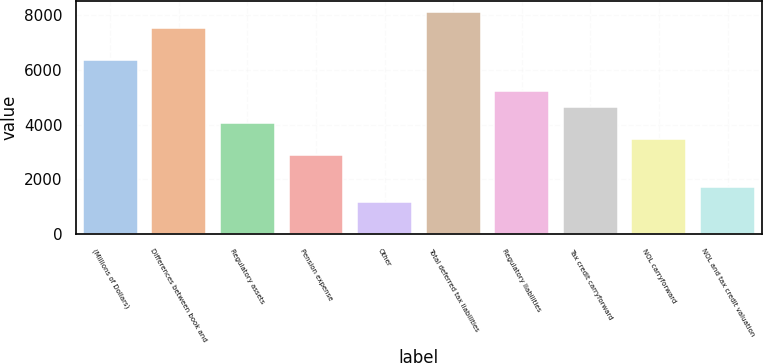<chart> <loc_0><loc_0><loc_500><loc_500><bar_chart><fcel>(Millions of Dollars)<fcel>Differences between book and<fcel>Regulatory assets<fcel>Pension expense<fcel>Other<fcel>Total deferred tax liabilities<fcel>Regulatory liabilities<fcel>Tax credit carryforward<fcel>NOL carryforward<fcel>NOL and tax credit valuation<nl><fcel>6358.1<fcel>7512.3<fcel>4049.7<fcel>2895.5<fcel>1164.2<fcel>8089.4<fcel>5203.9<fcel>4626.8<fcel>3472.6<fcel>1741.3<nl></chart> 